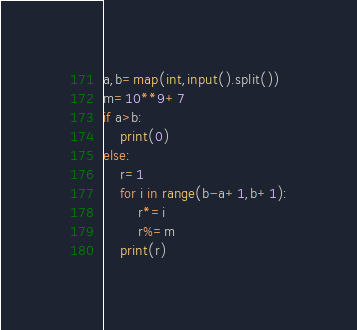<code> <loc_0><loc_0><loc_500><loc_500><_Python_>a,b=map(int,input().split())
m=10**9+7
if a>b:
	print(0)
else:
	r=1
	for i in range(b-a+1,b+1):
		r*=i
		r%=m
	print(r)
</code> 